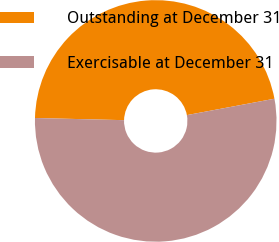Convert chart. <chart><loc_0><loc_0><loc_500><loc_500><pie_chart><fcel>Outstanding at December 31<fcel>Exercisable at December 31<nl><fcel>46.67%<fcel>53.33%<nl></chart> 